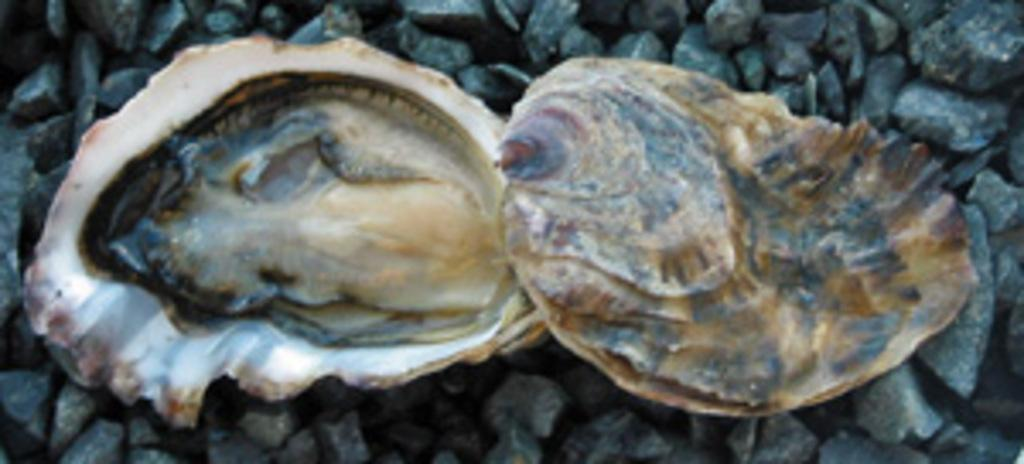What is the main subject of the image? The main subject of the image is an oyster. Where is the oyster located in the image? The oyster is on small stones in the image. What type of fruit is being cooked on the page in the image? There is no fruit, cooking, or page present in the image; it features an oyster on small stones. 